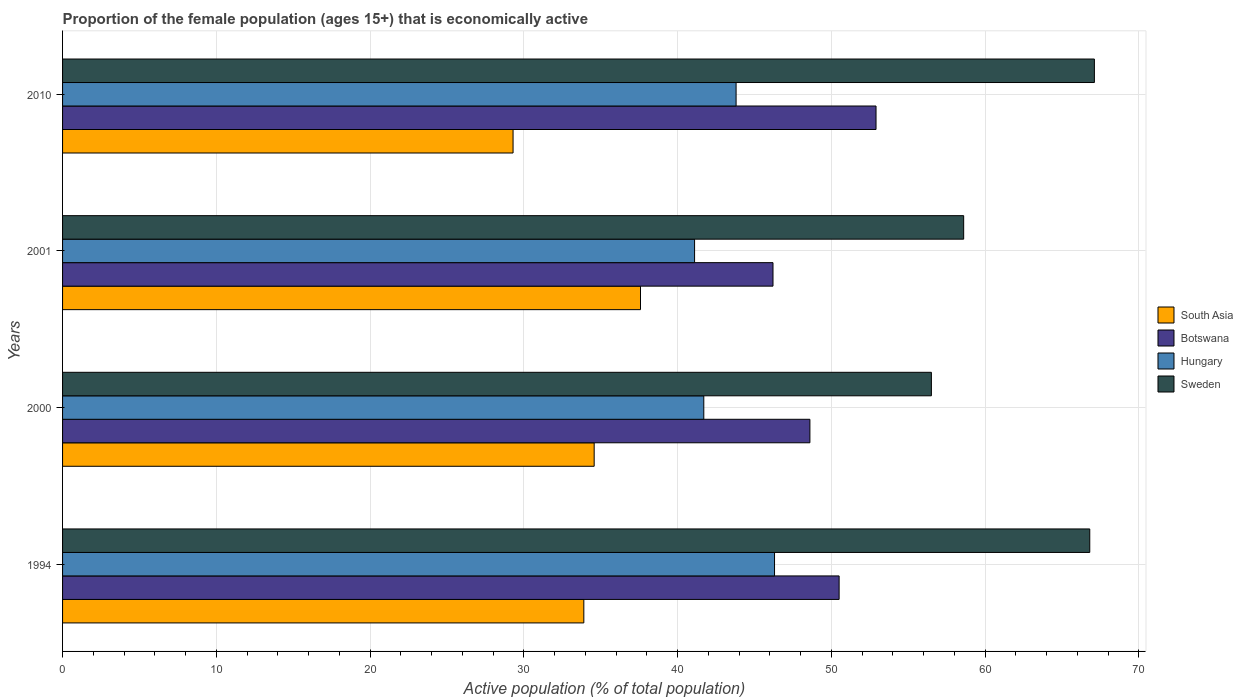How many different coloured bars are there?
Offer a terse response. 4. How many groups of bars are there?
Ensure brevity in your answer.  4. Are the number of bars per tick equal to the number of legend labels?
Provide a short and direct response. Yes. Are the number of bars on each tick of the Y-axis equal?
Give a very brief answer. Yes. How many bars are there on the 2nd tick from the top?
Your answer should be compact. 4. What is the label of the 2nd group of bars from the top?
Provide a short and direct response. 2001. What is the proportion of the female population that is economically active in South Asia in 2010?
Your answer should be very brief. 29.3. Across all years, what is the maximum proportion of the female population that is economically active in Botswana?
Offer a very short reply. 52.9. Across all years, what is the minimum proportion of the female population that is economically active in South Asia?
Give a very brief answer. 29.3. In which year was the proportion of the female population that is economically active in Sweden maximum?
Your answer should be very brief. 2010. In which year was the proportion of the female population that is economically active in Hungary minimum?
Your response must be concise. 2001. What is the total proportion of the female population that is economically active in South Asia in the graph?
Provide a short and direct response. 135.35. What is the difference between the proportion of the female population that is economically active in Hungary in 2000 and that in 2010?
Keep it short and to the point. -2.1. What is the difference between the proportion of the female population that is economically active in South Asia in 2000 and the proportion of the female population that is economically active in Botswana in 2001?
Provide a succinct answer. -11.63. What is the average proportion of the female population that is economically active in Hungary per year?
Provide a short and direct response. 43.22. In the year 2001, what is the difference between the proportion of the female population that is economically active in Hungary and proportion of the female population that is economically active in Botswana?
Your response must be concise. -5.1. In how many years, is the proportion of the female population that is economically active in Hungary greater than 46 %?
Your answer should be compact. 1. What is the ratio of the proportion of the female population that is economically active in South Asia in 2000 to that in 2010?
Give a very brief answer. 1.18. Is the proportion of the female population that is economically active in South Asia in 1994 less than that in 2000?
Your answer should be compact. Yes. What is the difference between the highest and the lowest proportion of the female population that is economically active in Hungary?
Your response must be concise. 5.2. In how many years, is the proportion of the female population that is economically active in Sweden greater than the average proportion of the female population that is economically active in Sweden taken over all years?
Make the answer very short. 2. Is the sum of the proportion of the female population that is economically active in Hungary in 1994 and 2000 greater than the maximum proportion of the female population that is economically active in South Asia across all years?
Offer a terse response. Yes. Is it the case that in every year, the sum of the proportion of the female population that is economically active in South Asia and proportion of the female population that is economically active in Sweden is greater than the sum of proportion of the female population that is economically active in Botswana and proportion of the female population that is economically active in Hungary?
Offer a terse response. No. What does the 3rd bar from the top in 2010 represents?
Keep it short and to the point. Botswana. What does the 4th bar from the bottom in 2010 represents?
Ensure brevity in your answer.  Sweden. Are all the bars in the graph horizontal?
Offer a very short reply. Yes. What is the difference between two consecutive major ticks on the X-axis?
Your answer should be compact. 10. How many legend labels are there?
Your answer should be very brief. 4. How are the legend labels stacked?
Your response must be concise. Vertical. What is the title of the graph?
Your answer should be very brief. Proportion of the female population (ages 15+) that is economically active. What is the label or title of the X-axis?
Keep it short and to the point. Active population (% of total population). What is the label or title of the Y-axis?
Your answer should be very brief. Years. What is the Active population (% of total population) of South Asia in 1994?
Your response must be concise. 33.9. What is the Active population (% of total population) in Botswana in 1994?
Give a very brief answer. 50.5. What is the Active population (% of total population) of Hungary in 1994?
Your answer should be compact. 46.3. What is the Active population (% of total population) of Sweden in 1994?
Offer a very short reply. 66.8. What is the Active population (% of total population) in South Asia in 2000?
Provide a succinct answer. 34.57. What is the Active population (% of total population) of Botswana in 2000?
Ensure brevity in your answer.  48.6. What is the Active population (% of total population) of Hungary in 2000?
Ensure brevity in your answer.  41.7. What is the Active population (% of total population) of Sweden in 2000?
Your response must be concise. 56.5. What is the Active population (% of total population) of South Asia in 2001?
Offer a terse response. 37.58. What is the Active population (% of total population) in Botswana in 2001?
Your response must be concise. 46.2. What is the Active population (% of total population) of Hungary in 2001?
Ensure brevity in your answer.  41.1. What is the Active population (% of total population) of Sweden in 2001?
Give a very brief answer. 58.6. What is the Active population (% of total population) of South Asia in 2010?
Give a very brief answer. 29.3. What is the Active population (% of total population) of Botswana in 2010?
Give a very brief answer. 52.9. What is the Active population (% of total population) in Hungary in 2010?
Make the answer very short. 43.8. What is the Active population (% of total population) in Sweden in 2010?
Your response must be concise. 67.1. Across all years, what is the maximum Active population (% of total population) of South Asia?
Your answer should be very brief. 37.58. Across all years, what is the maximum Active population (% of total population) in Botswana?
Provide a short and direct response. 52.9. Across all years, what is the maximum Active population (% of total population) of Hungary?
Your answer should be very brief. 46.3. Across all years, what is the maximum Active population (% of total population) of Sweden?
Your answer should be very brief. 67.1. Across all years, what is the minimum Active population (% of total population) in South Asia?
Ensure brevity in your answer.  29.3. Across all years, what is the minimum Active population (% of total population) in Botswana?
Your answer should be very brief. 46.2. Across all years, what is the minimum Active population (% of total population) in Hungary?
Offer a very short reply. 41.1. Across all years, what is the minimum Active population (% of total population) in Sweden?
Ensure brevity in your answer.  56.5. What is the total Active population (% of total population) in South Asia in the graph?
Give a very brief answer. 135.35. What is the total Active population (% of total population) in Botswana in the graph?
Ensure brevity in your answer.  198.2. What is the total Active population (% of total population) in Hungary in the graph?
Ensure brevity in your answer.  172.9. What is the total Active population (% of total population) in Sweden in the graph?
Your response must be concise. 249. What is the difference between the Active population (% of total population) in South Asia in 1994 and that in 2000?
Offer a very short reply. -0.67. What is the difference between the Active population (% of total population) of Sweden in 1994 and that in 2000?
Offer a very short reply. 10.3. What is the difference between the Active population (% of total population) of South Asia in 1994 and that in 2001?
Provide a succinct answer. -3.68. What is the difference between the Active population (% of total population) in Hungary in 1994 and that in 2001?
Your answer should be very brief. 5.2. What is the difference between the Active population (% of total population) of Sweden in 1994 and that in 2001?
Give a very brief answer. 8.2. What is the difference between the Active population (% of total population) of South Asia in 1994 and that in 2010?
Your response must be concise. 4.6. What is the difference between the Active population (% of total population) in South Asia in 2000 and that in 2001?
Offer a terse response. -3.01. What is the difference between the Active population (% of total population) of Botswana in 2000 and that in 2001?
Offer a very short reply. 2.4. What is the difference between the Active population (% of total population) in South Asia in 2000 and that in 2010?
Give a very brief answer. 5.27. What is the difference between the Active population (% of total population) of Sweden in 2000 and that in 2010?
Provide a short and direct response. -10.6. What is the difference between the Active population (% of total population) of South Asia in 2001 and that in 2010?
Your response must be concise. 8.29. What is the difference between the Active population (% of total population) in Hungary in 2001 and that in 2010?
Give a very brief answer. -2.7. What is the difference between the Active population (% of total population) of South Asia in 1994 and the Active population (% of total population) of Botswana in 2000?
Give a very brief answer. -14.7. What is the difference between the Active population (% of total population) of South Asia in 1994 and the Active population (% of total population) of Hungary in 2000?
Make the answer very short. -7.8. What is the difference between the Active population (% of total population) of South Asia in 1994 and the Active population (% of total population) of Sweden in 2000?
Offer a terse response. -22.6. What is the difference between the Active population (% of total population) of Botswana in 1994 and the Active population (% of total population) of Hungary in 2000?
Your answer should be very brief. 8.8. What is the difference between the Active population (% of total population) of South Asia in 1994 and the Active population (% of total population) of Botswana in 2001?
Provide a succinct answer. -12.3. What is the difference between the Active population (% of total population) of South Asia in 1994 and the Active population (% of total population) of Hungary in 2001?
Keep it short and to the point. -7.2. What is the difference between the Active population (% of total population) in South Asia in 1994 and the Active population (% of total population) in Sweden in 2001?
Offer a terse response. -24.7. What is the difference between the Active population (% of total population) of South Asia in 1994 and the Active population (% of total population) of Botswana in 2010?
Your answer should be very brief. -19. What is the difference between the Active population (% of total population) of South Asia in 1994 and the Active population (% of total population) of Hungary in 2010?
Offer a terse response. -9.9. What is the difference between the Active population (% of total population) in South Asia in 1994 and the Active population (% of total population) in Sweden in 2010?
Make the answer very short. -33.2. What is the difference between the Active population (% of total population) of Botswana in 1994 and the Active population (% of total population) of Hungary in 2010?
Your answer should be very brief. 6.7. What is the difference between the Active population (% of total population) of Botswana in 1994 and the Active population (% of total population) of Sweden in 2010?
Provide a short and direct response. -16.6. What is the difference between the Active population (% of total population) of Hungary in 1994 and the Active population (% of total population) of Sweden in 2010?
Offer a very short reply. -20.8. What is the difference between the Active population (% of total population) in South Asia in 2000 and the Active population (% of total population) in Botswana in 2001?
Offer a terse response. -11.63. What is the difference between the Active population (% of total population) in South Asia in 2000 and the Active population (% of total population) in Hungary in 2001?
Give a very brief answer. -6.53. What is the difference between the Active population (% of total population) in South Asia in 2000 and the Active population (% of total population) in Sweden in 2001?
Your answer should be very brief. -24.03. What is the difference between the Active population (% of total population) of Botswana in 2000 and the Active population (% of total population) of Sweden in 2001?
Your answer should be compact. -10. What is the difference between the Active population (% of total population) of Hungary in 2000 and the Active population (% of total population) of Sweden in 2001?
Your answer should be compact. -16.9. What is the difference between the Active population (% of total population) in South Asia in 2000 and the Active population (% of total population) in Botswana in 2010?
Provide a short and direct response. -18.33. What is the difference between the Active population (% of total population) in South Asia in 2000 and the Active population (% of total population) in Hungary in 2010?
Offer a very short reply. -9.23. What is the difference between the Active population (% of total population) in South Asia in 2000 and the Active population (% of total population) in Sweden in 2010?
Keep it short and to the point. -32.53. What is the difference between the Active population (% of total population) of Botswana in 2000 and the Active population (% of total population) of Hungary in 2010?
Offer a very short reply. 4.8. What is the difference between the Active population (% of total population) of Botswana in 2000 and the Active population (% of total population) of Sweden in 2010?
Your answer should be very brief. -18.5. What is the difference between the Active population (% of total population) of Hungary in 2000 and the Active population (% of total population) of Sweden in 2010?
Your response must be concise. -25.4. What is the difference between the Active population (% of total population) of South Asia in 2001 and the Active population (% of total population) of Botswana in 2010?
Your answer should be compact. -15.32. What is the difference between the Active population (% of total population) in South Asia in 2001 and the Active population (% of total population) in Hungary in 2010?
Provide a succinct answer. -6.22. What is the difference between the Active population (% of total population) of South Asia in 2001 and the Active population (% of total population) of Sweden in 2010?
Provide a short and direct response. -29.52. What is the difference between the Active population (% of total population) of Botswana in 2001 and the Active population (% of total population) of Sweden in 2010?
Make the answer very short. -20.9. What is the average Active population (% of total population) in South Asia per year?
Offer a very short reply. 33.84. What is the average Active population (% of total population) in Botswana per year?
Keep it short and to the point. 49.55. What is the average Active population (% of total population) of Hungary per year?
Your answer should be very brief. 43.23. What is the average Active population (% of total population) in Sweden per year?
Your answer should be very brief. 62.25. In the year 1994, what is the difference between the Active population (% of total population) of South Asia and Active population (% of total population) of Botswana?
Your answer should be very brief. -16.6. In the year 1994, what is the difference between the Active population (% of total population) in South Asia and Active population (% of total population) in Hungary?
Give a very brief answer. -12.4. In the year 1994, what is the difference between the Active population (% of total population) of South Asia and Active population (% of total population) of Sweden?
Your answer should be compact. -32.9. In the year 1994, what is the difference between the Active population (% of total population) of Botswana and Active population (% of total population) of Hungary?
Offer a very short reply. 4.2. In the year 1994, what is the difference between the Active population (% of total population) of Botswana and Active population (% of total population) of Sweden?
Your response must be concise. -16.3. In the year 1994, what is the difference between the Active population (% of total population) in Hungary and Active population (% of total population) in Sweden?
Your response must be concise. -20.5. In the year 2000, what is the difference between the Active population (% of total population) of South Asia and Active population (% of total population) of Botswana?
Offer a very short reply. -14.03. In the year 2000, what is the difference between the Active population (% of total population) of South Asia and Active population (% of total population) of Hungary?
Your answer should be compact. -7.13. In the year 2000, what is the difference between the Active population (% of total population) in South Asia and Active population (% of total population) in Sweden?
Your answer should be very brief. -21.93. In the year 2000, what is the difference between the Active population (% of total population) of Hungary and Active population (% of total population) of Sweden?
Your answer should be compact. -14.8. In the year 2001, what is the difference between the Active population (% of total population) in South Asia and Active population (% of total population) in Botswana?
Keep it short and to the point. -8.62. In the year 2001, what is the difference between the Active population (% of total population) of South Asia and Active population (% of total population) of Hungary?
Your answer should be compact. -3.52. In the year 2001, what is the difference between the Active population (% of total population) of South Asia and Active population (% of total population) of Sweden?
Your response must be concise. -21.02. In the year 2001, what is the difference between the Active population (% of total population) in Botswana and Active population (% of total population) in Sweden?
Your answer should be very brief. -12.4. In the year 2001, what is the difference between the Active population (% of total population) of Hungary and Active population (% of total population) of Sweden?
Your answer should be very brief. -17.5. In the year 2010, what is the difference between the Active population (% of total population) in South Asia and Active population (% of total population) in Botswana?
Make the answer very short. -23.6. In the year 2010, what is the difference between the Active population (% of total population) of South Asia and Active population (% of total population) of Hungary?
Offer a terse response. -14.5. In the year 2010, what is the difference between the Active population (% of total population) of South Asia and Active population (% of total population) of Sweden?
Offer a very short reply. -37.8. In the year 2010, what is the difference between the Active population (% of total population) in Botswana and Active population (% of total population) in Hungary?
Give a very brief answer. 9.1. In the year 2010, what is the difference between the Active population (% of total population) of Hungary and Active population (% of total population) of Sweden?
Make the answer very short. -23.3. What is the ratio of the Active population (% of total population) in South Asia in 1994 to that in 2000?
Keep it short and to the point. 0.98. What is the ratio of the Active population (% of total population) in Botswana in 1994 to that in 2000?
Your answer should be compact. 1.04. What is the ratio of the Active population (% of total population) in Hungary in 1994 to that in 2000?
Your answer should be very brief. 1.11. What is the ratio of the Active population (% of total population) of Sweden in 1994 to that in 2000?
Ensure brevity in your answer.  1.18. What is the ratio of the Active population (% of total population) in South Asia in 1994 to that in 2001?
Keep it short and to the point. 0.9. What is the ratio of the Active population (% of total population) in Botswana in 1994 to that in 2001?
Make the answer very short. 1.09. What is the ratio of the Active population (% of total population) in Hungary in 1994 to that in 2001?
Your response must be concise. 1.13. What is the ratio of the Active population (% of total population) in Sweden in 1994 to that in 2001?
Your answer should be very brief. 1.14. What is the ratio of the Active population (% of total population) in South Asia in 1994 to that in 2010?
Provide a short and direct response. 1.16. What is the ratio of the Active population (% of total population) of Botswana in 1994 to that in 2010?
Your answer should be compact. 0.95. What is the ratio of the Active population (% of total population) of Hungary in 1994 to that in 2010?
Your answer should be very brief. 1.06. What is the ratio of the Active population (% of total population) of Sweden in 1994 to that in 2010?
Keep it short and to the point. 1. What is the ratio of the Active population (% of total population) of South Asia in 2000 to that in 2001?
Offer a very short reply. 0.92. What is the ratio of the Active population (% of total population) of Botswana in 2000 to that in 2001?
Your answer should be very brief. 1.05. What is the ratio of the Active population (% of total population) of Hungary in 2000 to that in 2001?
Provide a succinct answer. 1.01. What is the ratio of the Active population (% of total population) of Sweden in 2000 to that in 2001?
Keep it short and to the point. 0.96. What is the ratio of the Active population (% of total population) in South Asia in 2000 to that in 2010?
Provide a succinct answer. 1.18. What is the ratio of the Active population (% of total population) in Botswana in 2000 to that in 2010?
Keep it short and to the point. 0.92. What is the ratio of the Active population (% of total population) of Hungary in 2000 to that in 2010?
Provide a succinct answer. 0.95. What is the ratio of the Active population (% of total population) of Sweden in 2000 to that in 2010?
Give a very brief answer. 0.84. What is the ratio of the Active population (% of total population) of South Asia in 2001 to that in 2010?
Your answer should be very brief. 1.28. What is the ratio of the Active population (% of total population) of Botswana in 2001 to that in 2010?
Offer a very short reply. 0.87. What is the ratio of the Active population (% of total population) of Hungary in 2001 to that in 2010?
Offer a very short reply. 0.94. What is the ratio of the Active population (% of total population) of Sweden in 2001 to that in 2010?
Give a very brief answer. 0.87. What is the difference between the highest and the second highest Active population (% of total population) in South Asia?
Give a very brief answer. 3.01. What is the difference between the highest and the second highest Active population (% of total population) in Hungary?
Your response must be concise. 2.5. What is the difference between the highest and the second highest Active population (% of total population) of Sweden?
Offer a terse response. 0.3. What is the difference between the highest and the lowest Active population (% of total population) in South Asia?
Provide a succinct answer. 8.29. What is the difference between the highest and the lowest Active population (% of total population) of Botswana?
Offer a terse response. 6.7. What is the difference between the highest and the lowest Active population (% of total population) in Hungary?
Ensure brevity in your answer.  5.2. What is the difference between the highest and the lowest Active population (% of total population) of Sweden?
Your response must be concise. 10.6. 